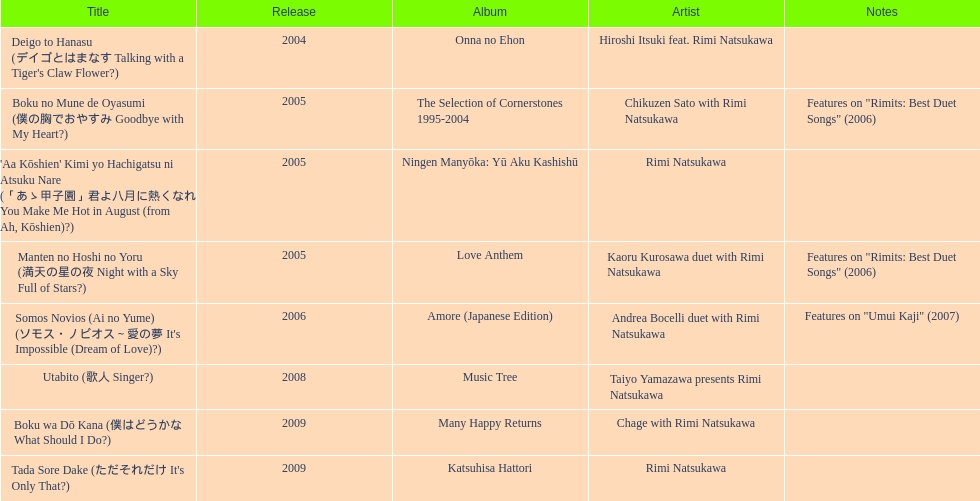What is the last title released? 2009. 